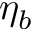<formula> <loc_0><loc_0><loc_500><loc_500>\eta _ { b }</formula> 